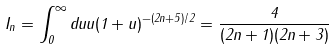Convert formula to latex. <formula><loc_0><loc_0><loc_500><loc_500>I _ { n } = \int _ { 0 } ^ { \infty } d u u ( 1 + u ) ^ { - ( 2 n + 5 ) / 2 } = \frac { 4 } { ( 2 n + 1 ) ( 2 n + 3 ) }</formula> 